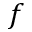<formula> <loc_0><loc_0><loc_500><loc_500>f</formula> 